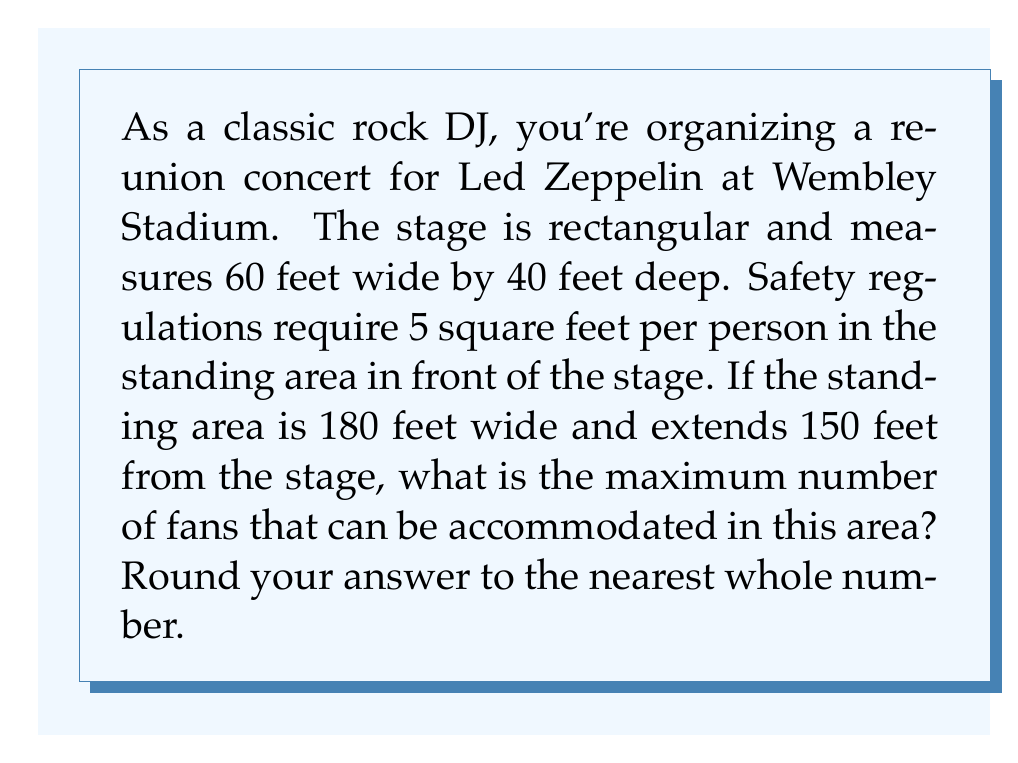Could you help me with this problem? To solve this problem, we need to follow these steps:

1. Calculate the area of the standing section:
   The standing area is also rectangular, with dimensions 180 feet wide and 150 feet deep.
   $$\text{Area} = \text{Width} \times \text{Depth}$$
   $$\text{Area} = 180 \text{ ft} \times 150 \text{ ft} = 27,000 \text{ sq ft}$$

2. Determine the number of people that can fit in this area:
   We know that safety regulations require 5 square feet per person.
   $$\text{Number of people} = \frac{\text{Total area}}{\text{Area per person}}$$
   $$\text{Number of people} = \frac{27,000 \text{ sq ft}}{5 \text{ sq ft/person}}$$
   $$\text{Number of people} = 5,400$$

3. Round to the nearest whole number:
   In this case, 5,400 is already a whole number, so no rounding is necessary.

Therefore, the maximum number of fans that can be accommodated in the standing area is 5,400.
Answer: 5,400 fans 